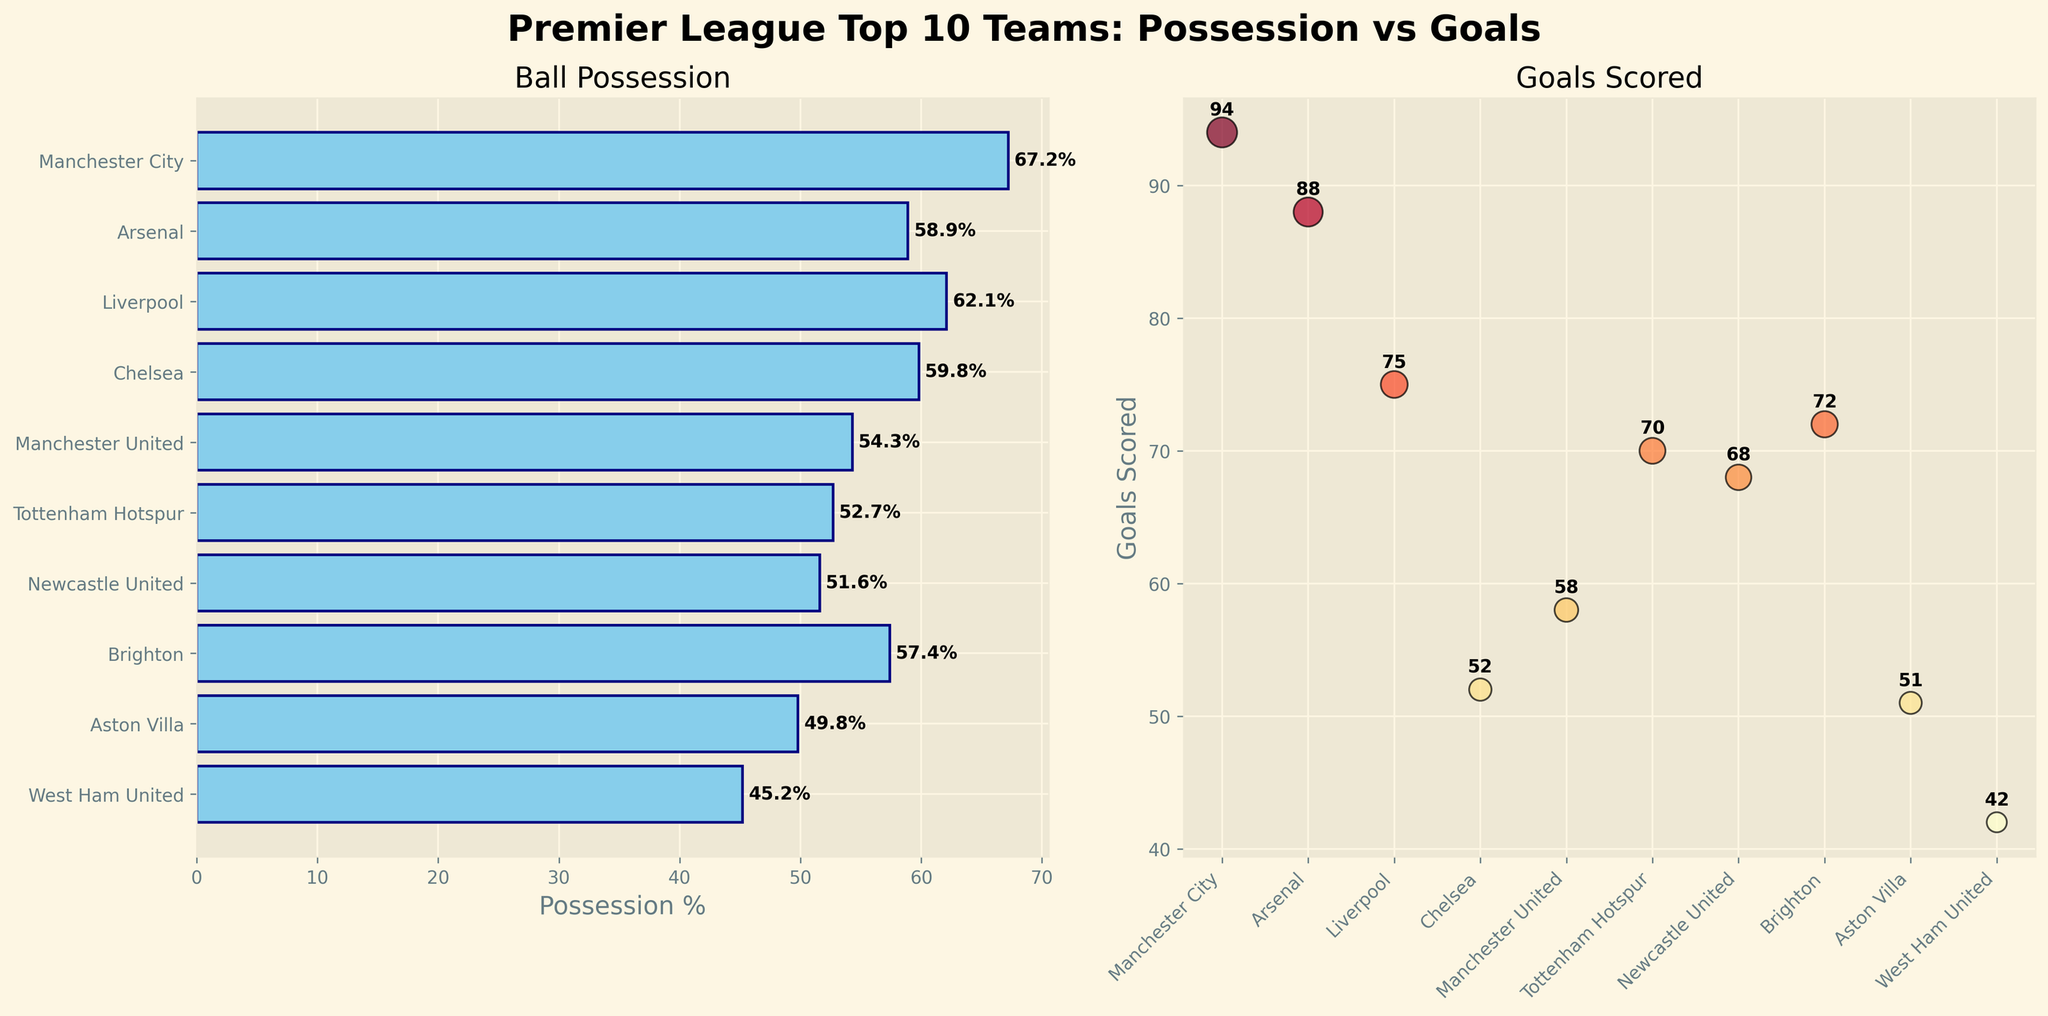Which team has the highest possession percentage? The bar plot on the left shows the possession percentages of the teams. Manchester City has the longest bar, indicating the highest possession percentage.
Answer: Manchester City Which team scored the most goals? The scatter plot on the right shows the goals scored by the teams. Manchester City has the highest point on the y-axis, indicating they scored the most goals.
Answer: Manchester City How does Chelsea's possession percentage compare to Arsenal's? On the bar plot, locate Chelsea and Arsenal. Chelsea's possession bar is at 59.8%, while Arsenal's is at 58.9%. Chelsea has a slightly higher possession percentage.
Answer: Chelsea has a higher possession percentage What is the combined possession percentage of Brighton and Tottenham Hotspur? On the bar plot, Brighton's possession percentage is 57.4%, and Tottenham Hotspur's is 52.7%. Adding these values together: 57.4 + 52.7.
Answer: 110.1% Which team has the lowest goals scored? The scatter plot shows the goals scored. West Ham United has the lowest point on the y-axis, indicating they scored the fewest goals.
Answer: West Ham United Is there a team with a lower possession percentage than goals scored? Compare the possession percentages and goals scored for each team. In all cases, possession percentages are higher than goals scored.
Answer: No What is the average possession percentage of the top 3 teams in terms of goals scored? The top three teams in goals scored are Manchester City (94), Arsenal (88), and Liverpool (75). Their possession percentages are 67.2%, 58.9%, and 62.1% respectively. Calculate the average: (67.2 + 58.9 + 62.1) / 3.
Answer: 62.73% Which team has the highest discrepancy between possession percentage and goals scored? Compare the difference between possession percentage and goals scored for each team. Chelsea has a large difference (59.8% possession, 52 goals), but Aston Villa’s discrepancy is larger (49.8% possession, 51 goals). Calculate discrepancies for confirmation.
Answer: Aston Villa How many teams have a possession percentage below 50%? On the bar plot, check which teams have bars below the 50% mark. Aston Villa and West Ham United both fall below 50%.
Answer: 2 teams 